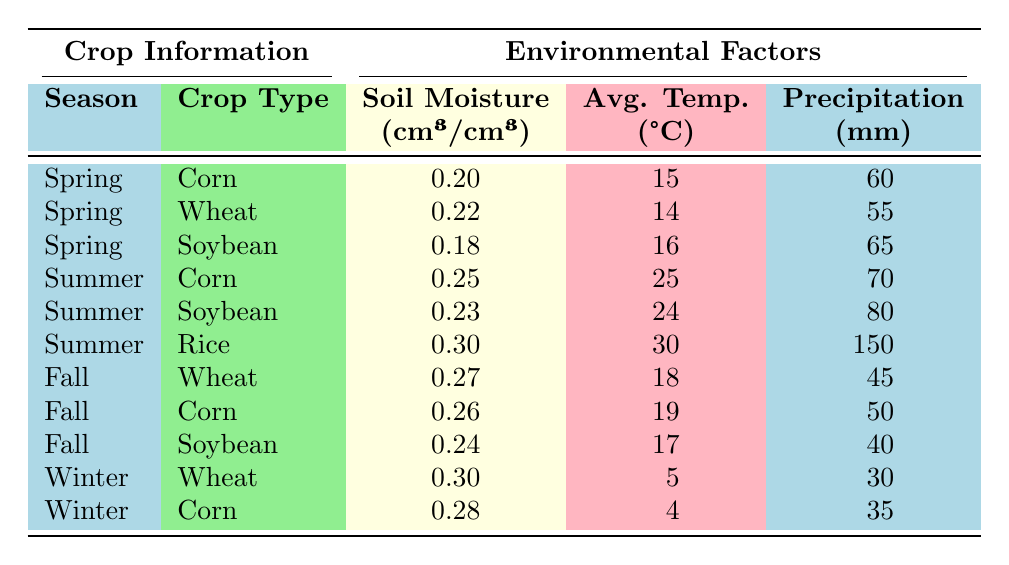What is the soil moisture level for Soybean in Spring? The table shows that in Spring, the Soil Moisture Level for Soybean is recorded as 0.18 cm³/cm³.
Answer: 0.18 cm³/cm³ What is the average temperature for Wheat in Fall? The table indicates that the Average Temperature for Wheat in Fall is 18°C.
Answer: 18°C Which crop type has the highest soil moisture level in Summer? In Summer, the table shows that Rice has the highest soil moisture level at 0.30 cm³/cm³ compared to Corn and Soybean.
Answer: Rice What is the difference in soil moisture level between Corn in Summer and Corn in Spring? The soil moisture level for Corn in Summer is 0.25 cm³/cm³, and for Spring, it is 0.20 cm³/cm³. The difference is 0.25 - 0.20 = 0.05 cm³/cm³.
Answer: 0.05 cm³/cm³ Which crop had the most precipitation in the Summer season? Looking at the table for Summer, Rice received the most precipitation with a total of 150 mm, more than Corn and Soybean.
Answer: Rice Is the average soil moisture level for Winter crops higher than for Spring crops? To determine this, calculate the average for Winter: (0.30 + 0.28) / 2 = 0.29 cm³/cm³. Spring average: (0.20 + 0.22 + 0.18) / 3 = 0.20 cm³/cm³. Since 0.29 > 0.20, Winter crops have a higher average soil moisture level.
Answer: Yes What is the total precipitation received by all crops in Fall? The total precipitation in Fall can be calculated by summing the values: 45 mm (Wheat) + 50 mm (Corn) + 40 mm (Soybean) = 135 mm.
Answer: 135 mm In which season do Soybeans receive the least average temperature? The table indicates that Soybean has an Average Temperature of 17°C in Fall, which is the least compared to the other seasons where they are listed.
Answer: Fall How does the soil moisture level change from Spring to Fall for Corn? In Spring, Corn's soil moisture is 0.20 cm³/cm³, while in Fall it is 0.26 cm³/cm³. The change is an increase of 0.26 - 0.20 = 0.06 cm³/cm³.
Answer: Increase of 0.06 cm³/cm³ What is the average soil moisture level across all seasons for Wheat? Wheat's soil moisture levels are 0.22 cm³/cm³ (Spring), 0.27 cm³/cm³ (Fall), and 0.30 cm³/cm³ (Winter). The average is (0.22 + 0.27 + 0.30) / 3 = 0.26 cm³/cm³.
Answer: 0.26 cm³/cm³ 